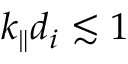<formula> <loc_0><loc_0><loc_500><loc_500>k _ { \| } d _ { i } \lesssim 1</formula> 